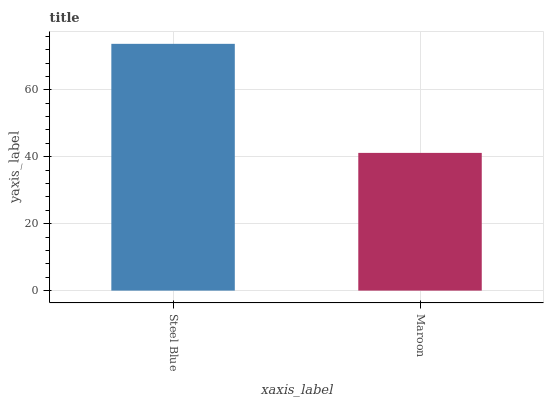Is Maroon the minimum?
Answer yes or no. Yes. Is Steel Blue the maximum?
Answer yes or no. Yes. Is Maroon the maximum?
Answer yes or no. No. Is Steel Blue greater than Maroon?
Answer yes or no. Yes. Is Maroon less than Steel Blue?
Answer yes or no. Yes. Is Maroon greater than Steel Blue?
Answer yes or no. No. Is Steel Blue less than Maroon?
Answer yes or no. No. Is Steel Blue the high median?
Answer yes or no. Yes. Is Maroon the low median?
Answer yes or no. Yes. Is Maroon the high median?
Answer yes or no. No. Is Steel Blue the low median?
Answer yes or no. No. 